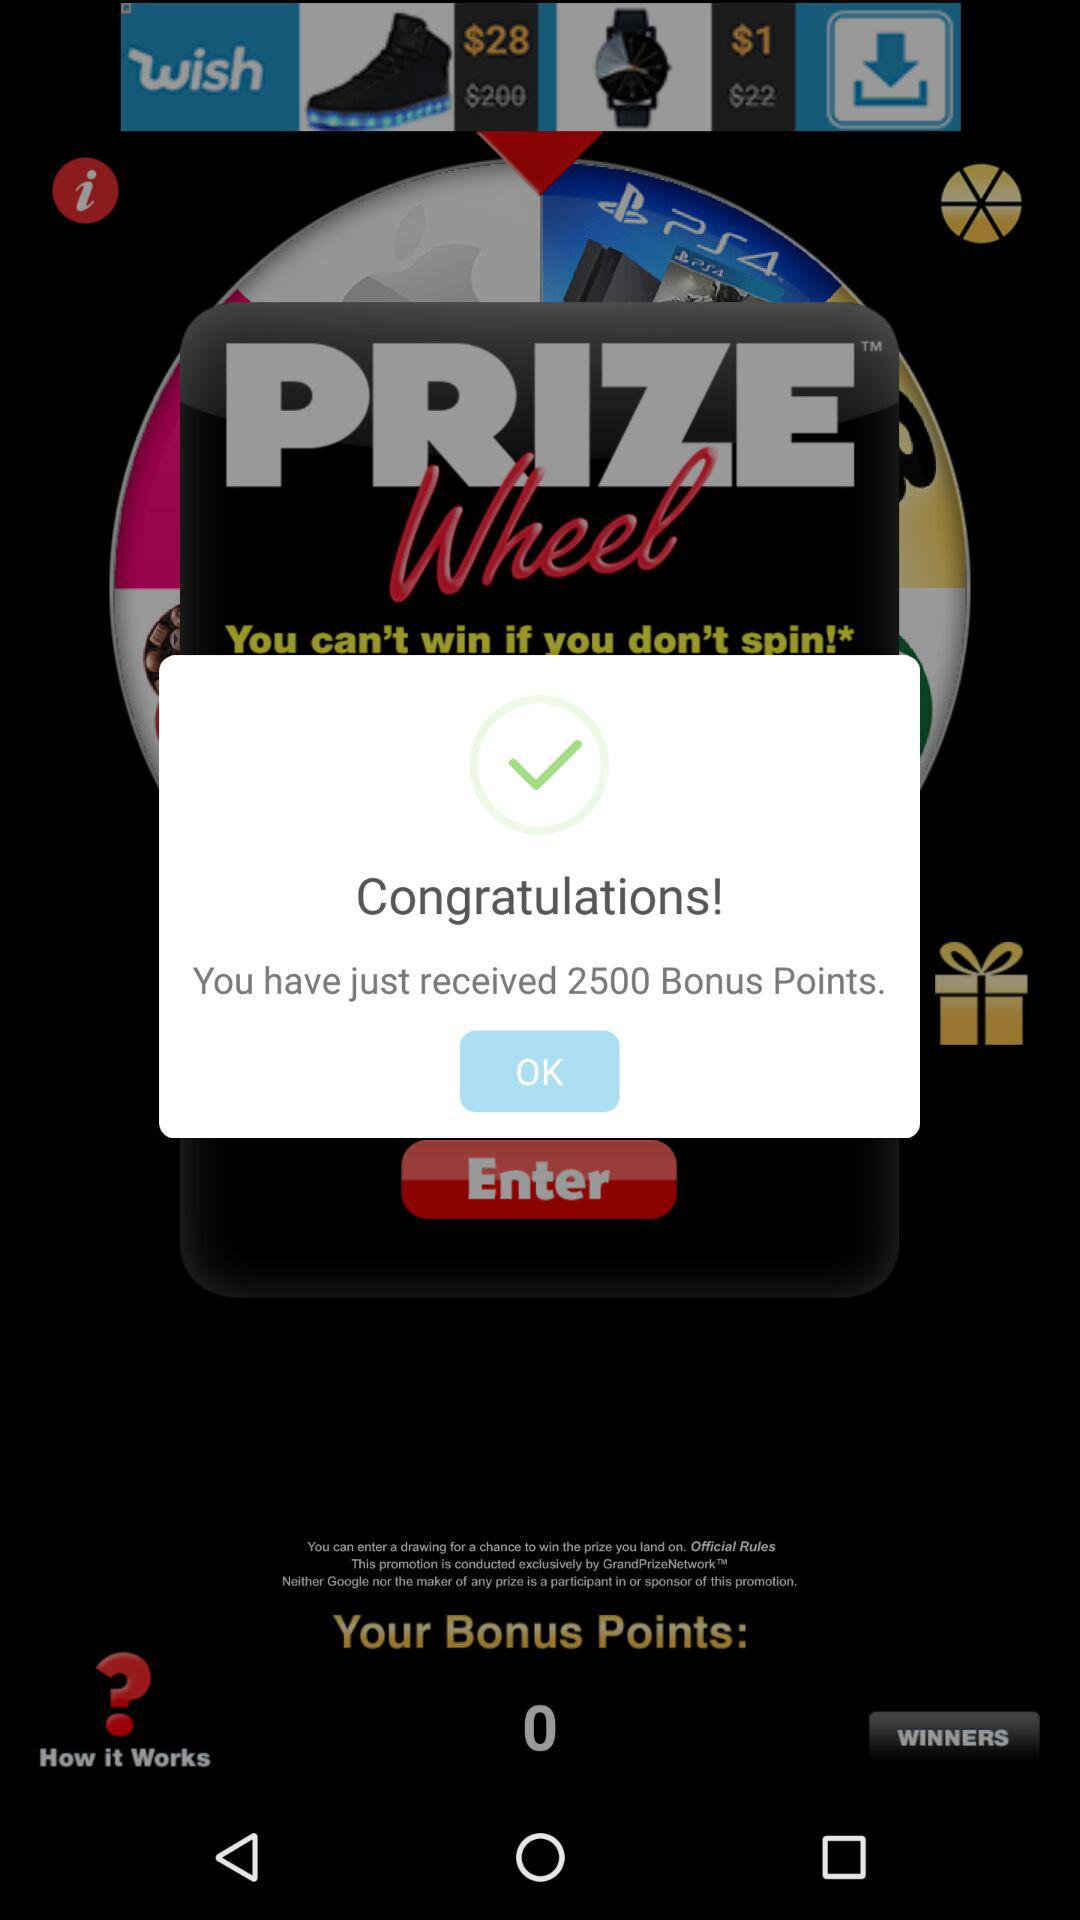How many bonus points do I have?
Answer the question using a single word or phrase. 2500 